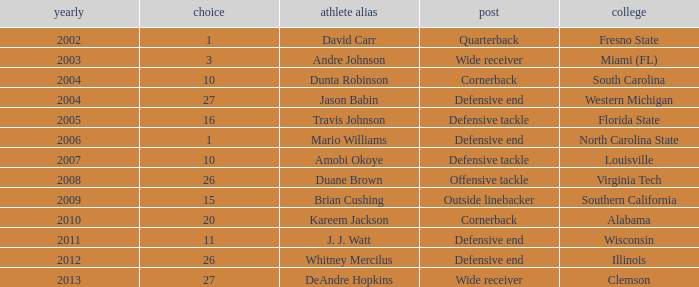What pick was mario williams before 2006? None. 